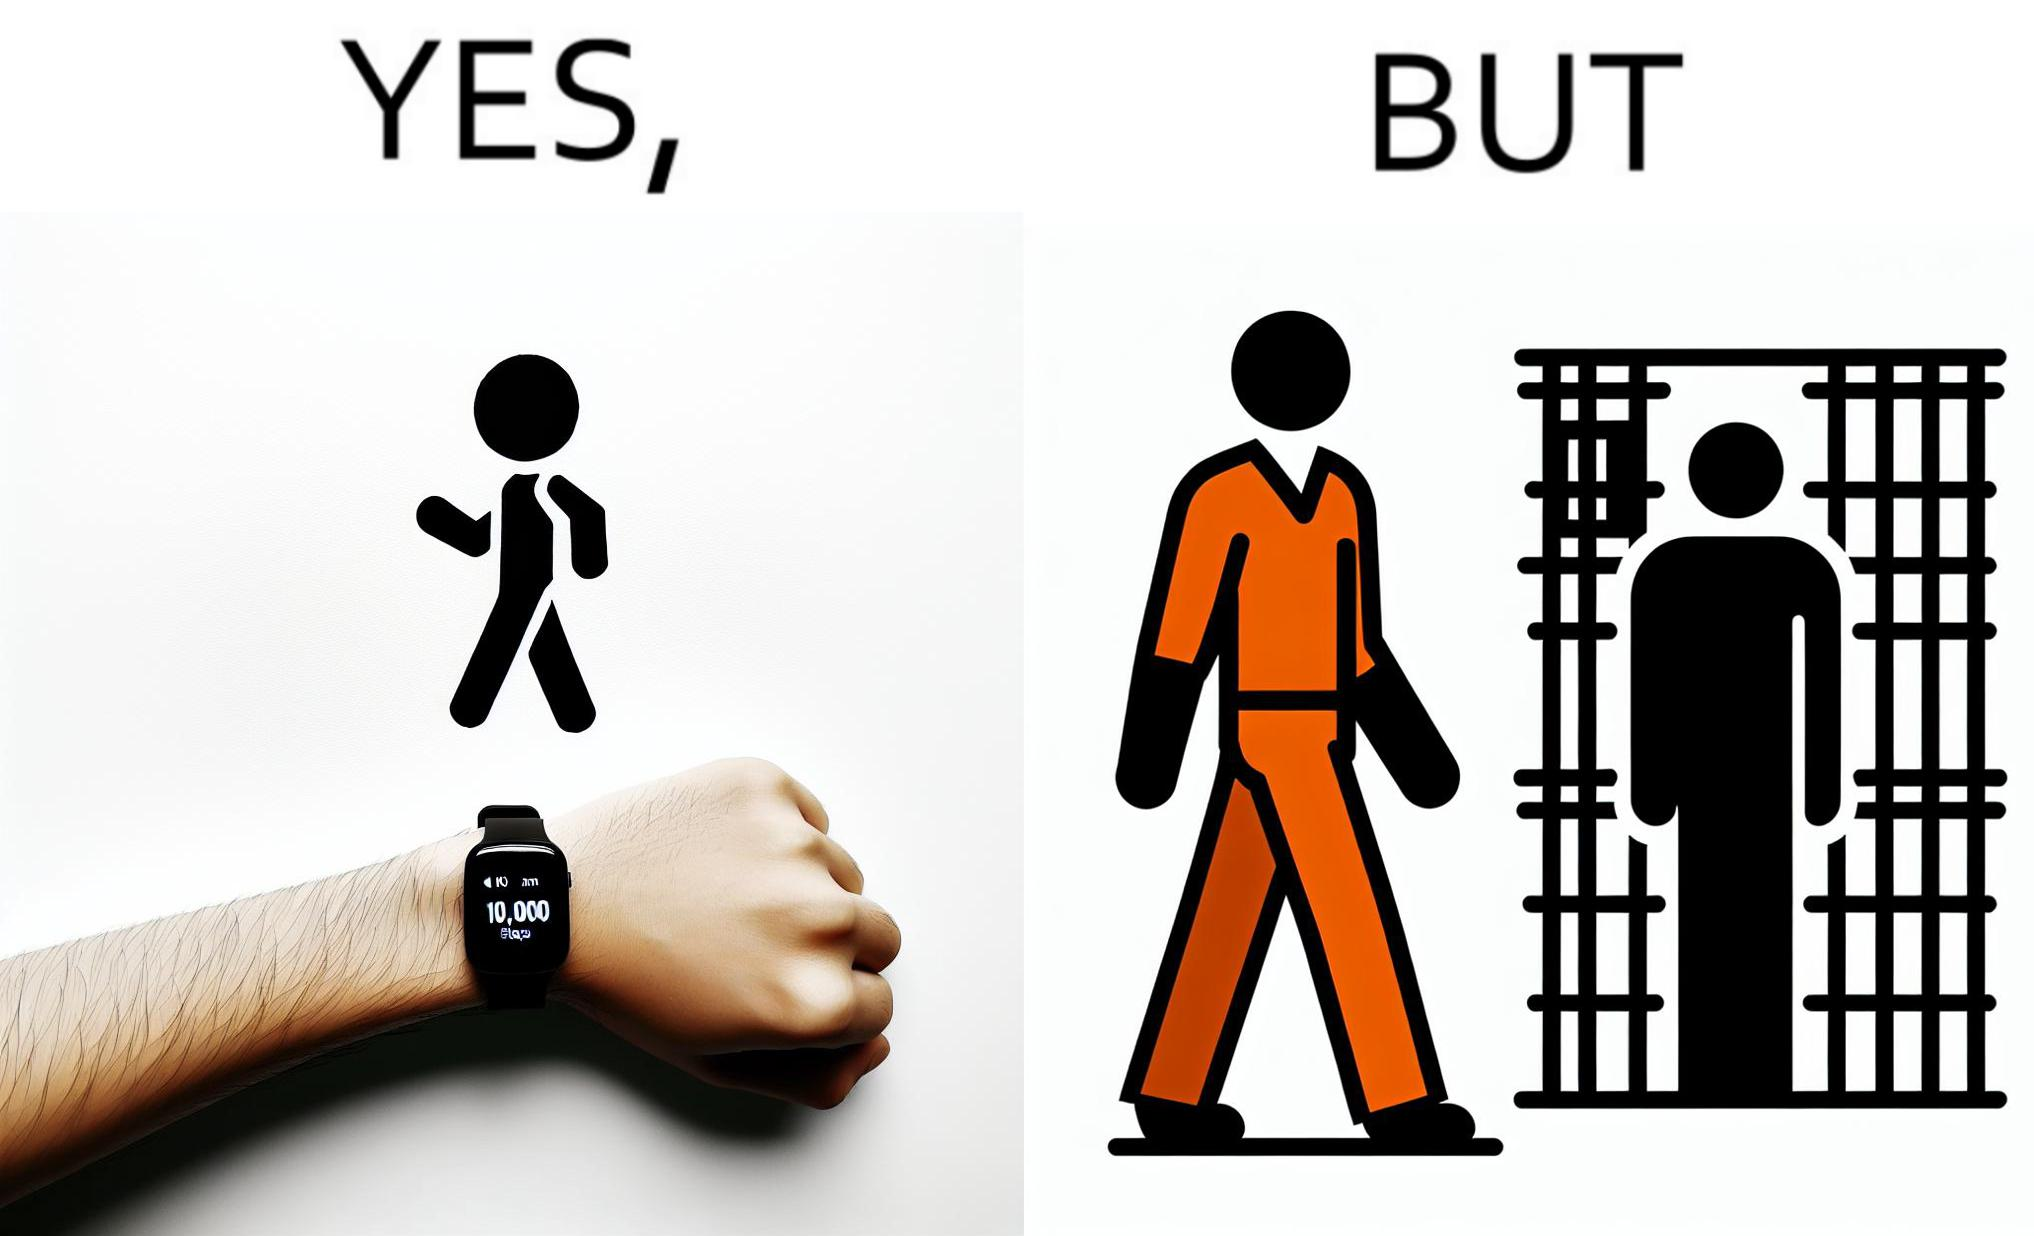Describe the satirical element in this image. The image is ironical, as the smartwatch on the person's wrist shows 10,000 steps completed as an accomplishment, while showing later that the person is apparently walking inside a jail as a prisoner. 